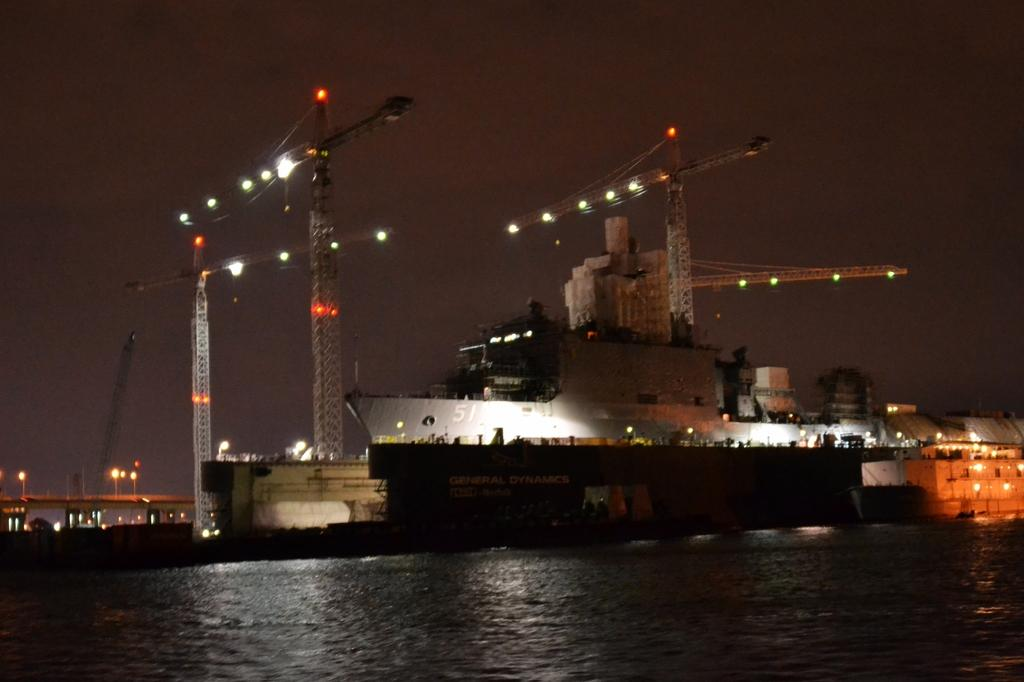What type of vehicles can be seen in the image? There are ships in the image. What is the primary element visible in the image? There is water visible in the image. What can be used to illuminate the image? There are lights in the image. What type of structure is present in the image? There is a building in the image. How would you describe the overall lighting in the image? The image is dark. What type of hot vessel can be seen in the image? There is no hot vessel present in the image; it features ships on water. Can you spot a pear in the image? There is no pear present in the image. 